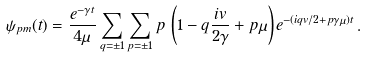Convert formula to latex. <formula><loc_0><loc_0><loc_500><loc_500>\psi _ { p m } ( t ) = \frac { e ^ { - \gamma t } } { 4 \mu } \sum _ { q = \pm 1 } \sum _ { p = \pm 1 } p \, \left ( 1 - q \frac { i v } { 2 \gamma } + p \mu \right ) e ^ { - ( i q v / 2 + p \gamma \mu ) t } \, .</formula> 